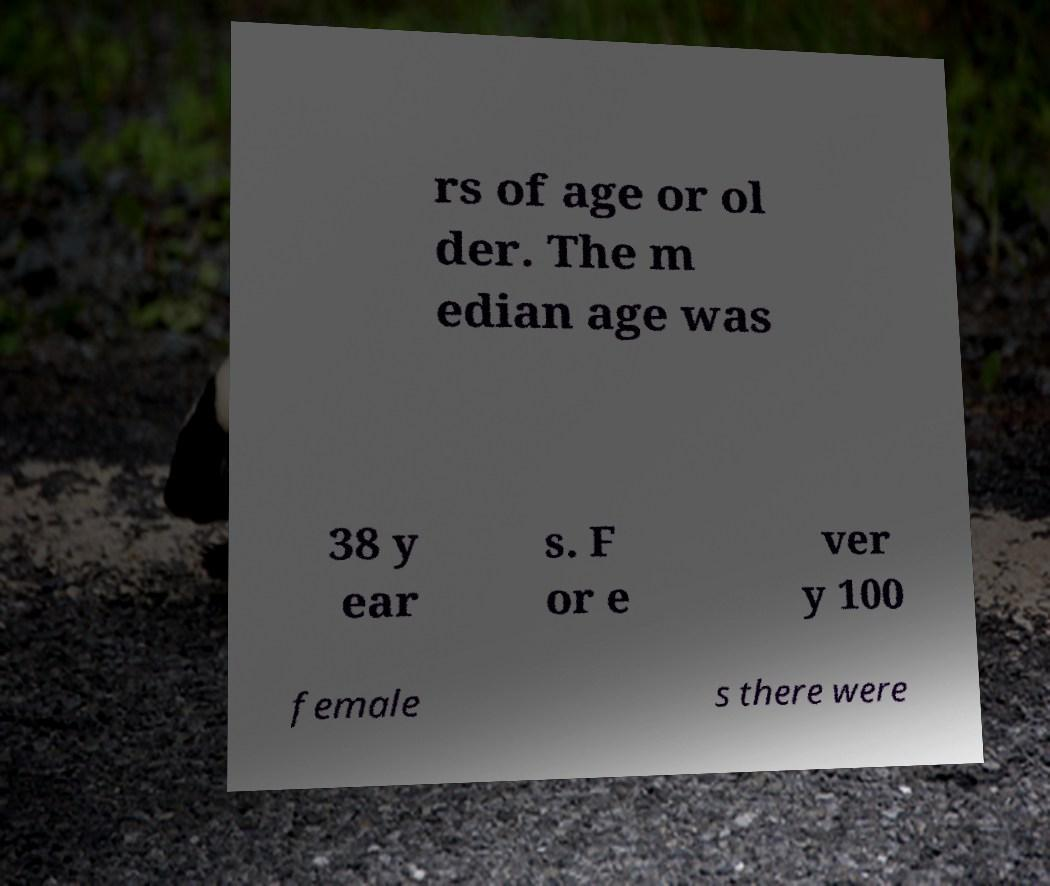I need the written content from this picture converted into text. Can you do that? rs of age or ol der. The m edian age was 38 y ear s. F or e ver y 100 female s there were 